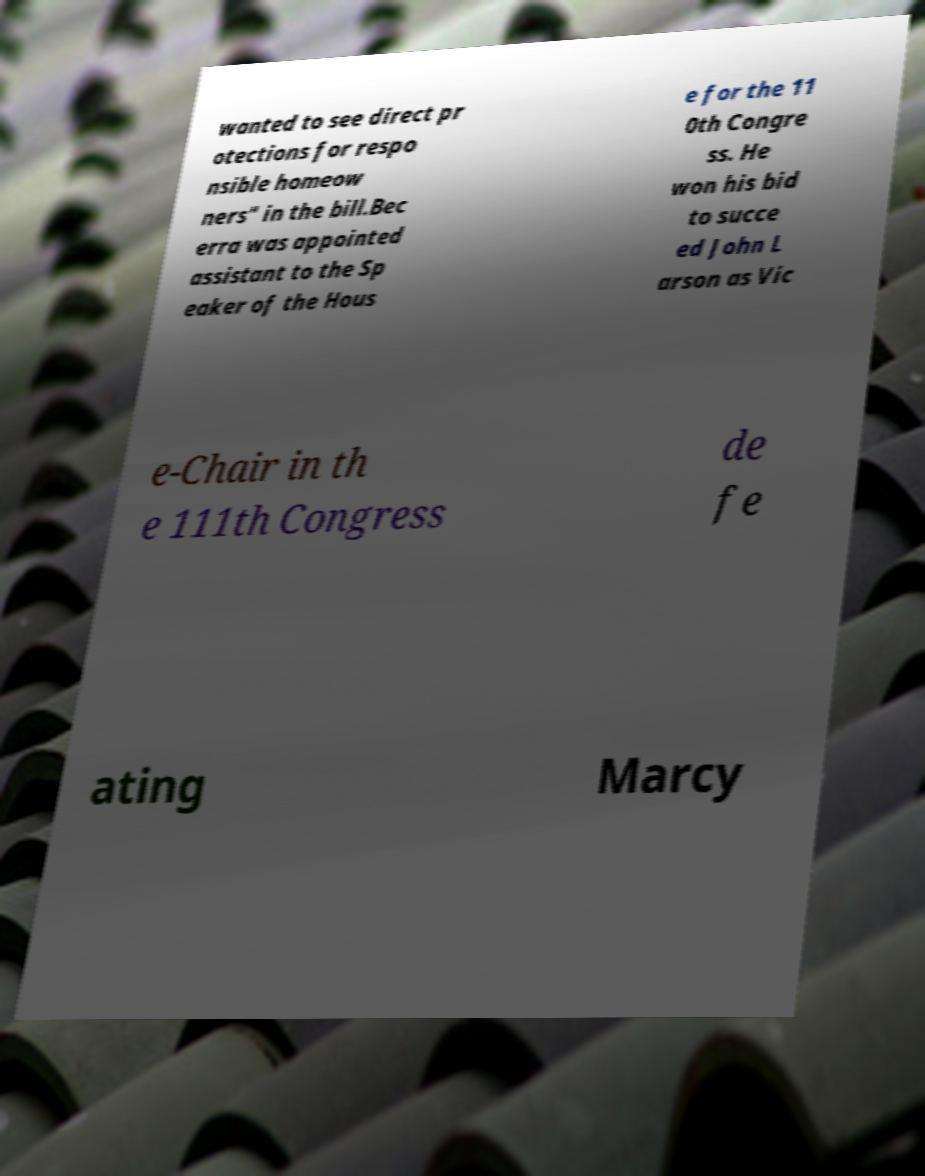Can you accurately transcribe the text from the provided image for me? wanted to see direct pr otections for respo nsible homeow ners" in the bill.Bec erra was appointed assistant to the Sp eaker of the Hous e for the 11 0th Congre ss. He won his bid to succe ed John L arson as Vic e-Chair in th e 111th Congress de fe ating Marcy 